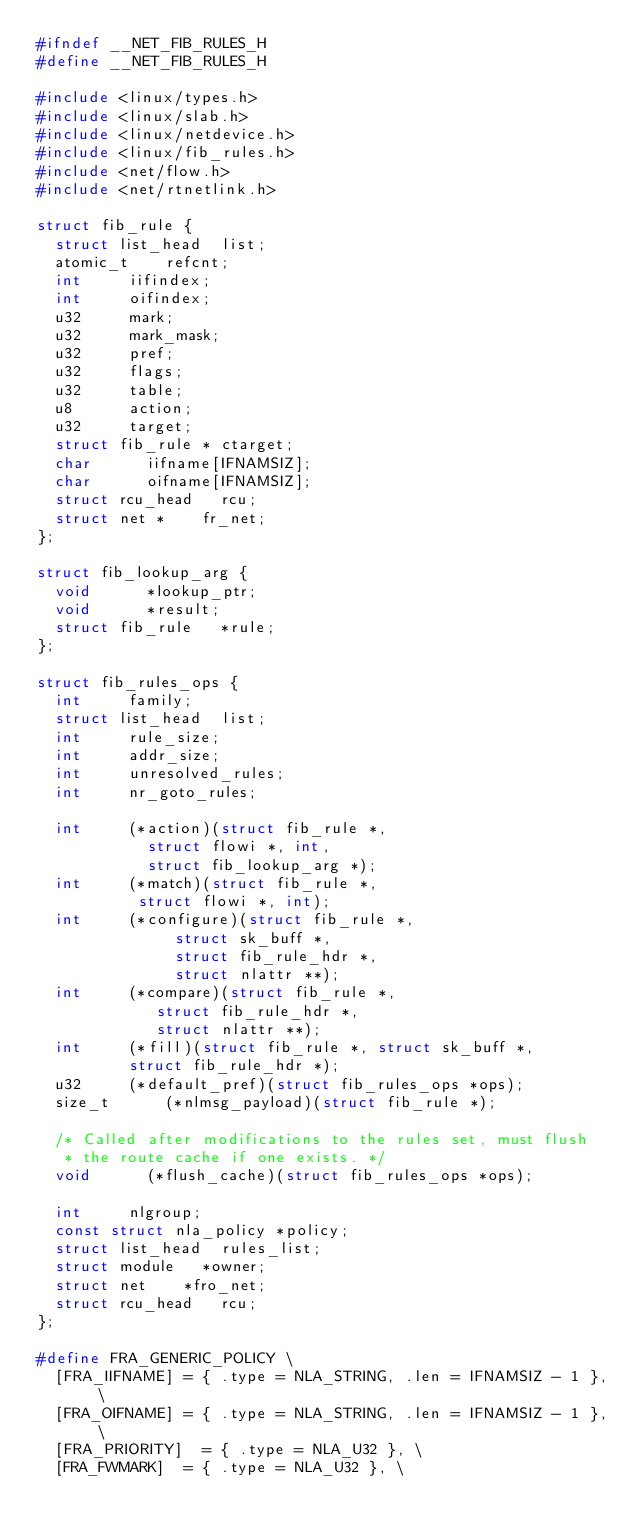Convert code to text. <code><loc_0><loc_0><loc_500><loc_500><_C_>#ifndef __NET_FIB_RULES_H
#define __NET_FIB_RULES_H

#include <linux/types.h>
#include <linux/slab.h>
#include <linux/netdevice.h>
#include <linux/fib_rules.h>
#include <net/flow.h>
#include <net/rtnetlink.h>

struct fib_rule {
	struct list_head	list;
	atomic_t		refcnt;
	int			iifindex;
	int			oifindex;
	u32			mark;
	u32			mark_mask;
	u32			pref;
	u32			flags;
	u32			table;
	u8			action;
	u32			target;
	struct fib_rule *	ctarget;
	char			iifname[IFNAMSIZ];
	char			oifname[IFNAMSIZ];
	struct rcu_head		rcu;
	struct net *		fr_net;
};

struct fib_lookup_arg {
	void			*lookup_ptr;
	void			*result;
	struct fib_rule		*rule;
};

struct fib_rules_ops {
	int			family;
	struct list_head	list;
	int			rule_size;
	int			addr_size;
	int			unresolved_rules;
	int			nr_goto_rules;

	int			(*action)(struct fib_rule *,
					  struct flowi *, int,
					  struct fib_lookup_arg *);
	int			(*match)(struct fib_rule *,
					 struct flowi *, int);
	int			(*configure)(struct fib_rule *,
					     struct sk_buff *,
					     struct fib_rule_hdr *,
					     struct nlattr **);
	int			(*compare)(struct fib_rule *,
					   struct fib_rule_hdr *,
					   struct nlattr **);
	int			(*fill)(struct fib_rule *, struct sk_buff *,
					struct fib_rule_hdr *);
	u32			(*default_pref)(struct fib_rules_ops *ops);
	size_t			(*nlmsg_payload)(struct fib_rule *);

	/* Called after modifications to the rules set, must flush
	 * the route cache if one exists. */
	void			(*flush_cache)(struct fib_rules_ops *ops);

	int			nlgroup;
	const struct nla_policy	*policy;
	struct list_head	rules_list;
	struct module		*owner;
	struct net		*fro_net;
	struct rcu_head		rcu;
};

#define FRA_GENERIC_POLICY \
	[FRA_IIFNAME]	= { .type = NLA_STRING, .len = IFNAMSIZ - 1 }, \
	[FRA_OIFNAME]	= { .type = NLA_STRING, .len = IFNAMSIZ - 1 }, \
	[FRA_PRIORITY]	= { .type = NLA_U32 }, \
	[FRA_FWMARK]	= { .type = NLA_U32 }, \</code> 